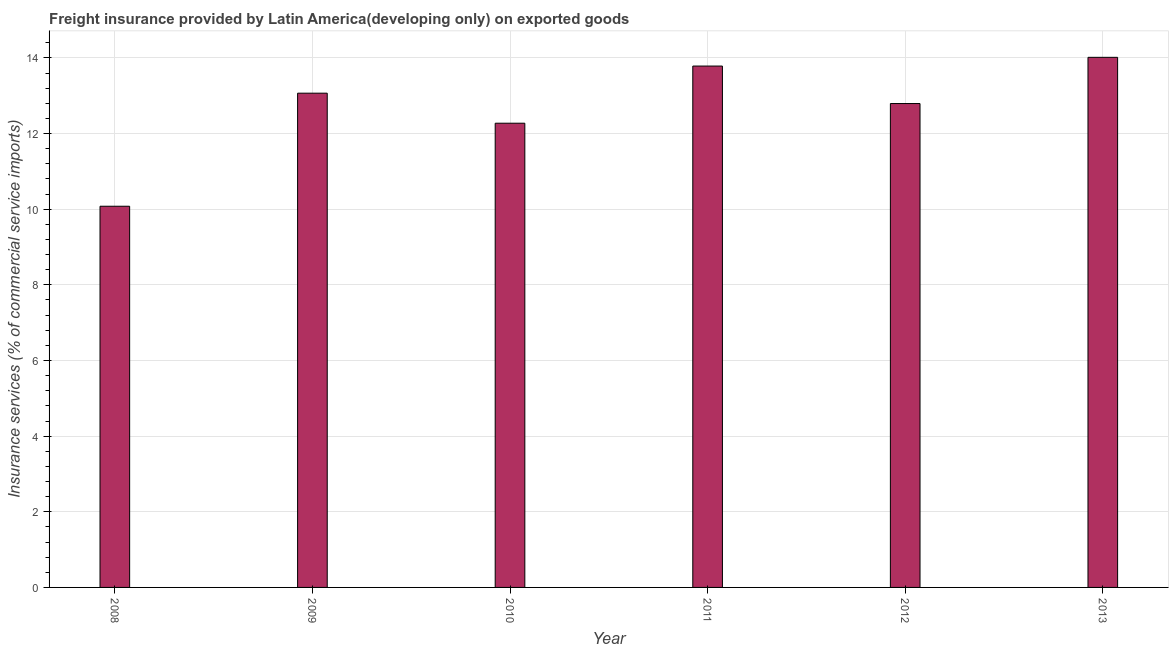What is the title of the graph?
Give a very brief answer. Freight insurance provided by Latin America(developing only) on exported goods . What is the label or title of the X-axis?
Your response must be concise. Year. What is the label or title of the Y-axis?
Provide a succinct answer. Insurance services (% of commercial service imports). What is the freight insurance in 2011?
Provide a short and direct response. 13.79. Across all years, what is the maximum freight insurance?
Your answer should be very brief. 14.02. Across all years, what is the minimum freight insurance?
Your response must be concise. 10.08. In which year was the freight insurance minimum?
Your answer should be compact. 2008. What is the sum of the freight insurance?
Your answer should be compact. 76.02. What is the difference between the freight insurance in 2009 and 2011?
Your response must be concise. -0.72. What is the average freight insurance per year?
Keep it short and to the point. 12.67. What is the median freight insurance?
Ensure brevity in your answer.  12.93. Is the freight insurance in 2009 less than that in 2012?
Your response must be concise. No. Is the difference between the freight insurance in 2010 and 2011 greater than the difference between any two years?
Your answer should be compact. No. What is the difference between the highest and the second highest freight insurance?
Ensure brevity in your answer.  0.23. Is the sum of the freight insurance in 2009 and 2011 greater than the maximum freight insurance across all years?
Keep it short and to the point. Yes. What is the difference between the highest and the lowest freight insurance?
Your answer should be compact. 3.94. How many years are there in the graph?
Your answer should be compact. 6. What is the Insurance services (% of commercial service imports) of 2008?
Ensure brevity in your answer.  10.08. What is the Insurance services (% of commercial service imports) of 2009?
Give a very brief answer. 13.07. What is the Insurance services (% of commercial service imports) in 2010?
Ensure brevity in your answer.  12.27. What is the Insurance services (% of commercial service imports) of 2011?
Give a very brief answer. 13.79. What is the Insurance services (% of commercial service imports) in 2012?
Provide a succinct answer. 12.79. What is the Insurance services (% of commercial service imports) of 2013?
Give a very brief answer. 14.02. What is the difference between the Insurance services (% of commercial service imports) in 2008 and 2009?
Your answer should be compact. -2.99. What is the difference between the Insurance services (% of commercial service imports) in 2008 and 2010?
Provide a short and direct response. -2.2. What is the difference between the Insurance services (% of commercial service imports) in 2008 and 2011?
Provide a succinct answer. -3.71. What is the difference between the Insurance services (% of commercial service imports) in 2008 and 2012?
Give a very brief answer. -2.72. What is the difference between the Insurance services (% of commercial service imports) in 2008 and 2013?
Keep it short and to the point. -3.94. What is the difference between the Insurance services (% of commercial service imports) in 2009 and 2010?
Provide a short and direct response. 0.79. What is the difference between the Insurance services (% of commercial service imports) in 2009 and 2011?
Offer a very short reply. -0.72. What is the difference between the Insurance services (% of commercial service imports) in 2009 and 2012?
Provide a short and direct response. 0.27. What is the difference between the Insurance services (% of commercial service imports) in 2009 and 2013?
Offer a terse response. -0.95. What is the difference between the Insurance services (% of commercial service imports) in 2010 and 2011?
Ensure brevity in your answer.  -1.51. What is the difference between the Insurance services (% of commercial service imports) in 2010 and 2012?
Ensure brevity in your answer.  -0.52. What is the difference between the Insurance services (% of commercial service imports) in 2010 and 2013?
Make the answer very short. -1.74. What is the difference between the Insurance services (% of commercial service imports) in 2011 and 2012?
Provide a short and direct response. 0.99. What is the difference between the Insurance services (% of commercial service imports) in 2011 and 2013?
Offer a terse response. -0.23. What is the difference between the Insurance services (% of commercial service imports) in 2012 and 2013?
Ensure brevity in your answer.  -1.22. What is the ratio of the Insurance services (% of commercial service imports) in 2008 to that in 2009?
Offer a terse response. 0.77. What is the ratio of the Insurance services (% of commercial service imports) in 2008 to that in 2010?
Your answer should be compact. 0.82. What is the ratio of the Insurance services (% of commercial service imports) in 2008 to that in 2011?
Provide a short and direct response. 0.73. What is the ratio of the Insurance services (% of commercial service imports) in 2008 to that in 2012?
Your answer should be compact. 0.79. What is the ratio of the Insurance services (% of commercial service imports) in 2008 to that in 2013?
Give a very brief answer. 0.72. What is the ratio of the Insurance services (% of commercial service imports) in 2009 to that in 2010?
Your response must be concise. 1.06. What is the ratio of the Insurance services (% of commercial service imports) in 2009 to that in 2011?
Provide a succinct answer. 0.95. What is the ratio of the Insurance services (% of commercial service imports) in 2009 to that in 2013?
Offer a very short reply. 0.93. What is the ratio of the Insurance services (% of commercial service imports) in 2010 to that in 2011?
Offer a terse response. 0.89. What is the ratio of the Insurance services (% of commercial service imports) in 2010 to that in 2012?
Provide a short and direct response. 0.96. What is the ratio of the Insurance services (% of commercial service imports) in 2010 to that in 2013?
Your answer should be compact. 0.88. What is the ratio of the Insurance services (% of commercial service imports) in 2011 to that in 2012?
Provide a short and direct response. 1.08. What is the ratio of the Insurance services (% of commercial service imports) in 2011 to that in 2013?
Provide a short and direct response. 0.98. What is the ratio of the Insurance services (% of commercial service imports) in 2012 to that in 2013?
Ensure brevity in your answer.  0.91. 